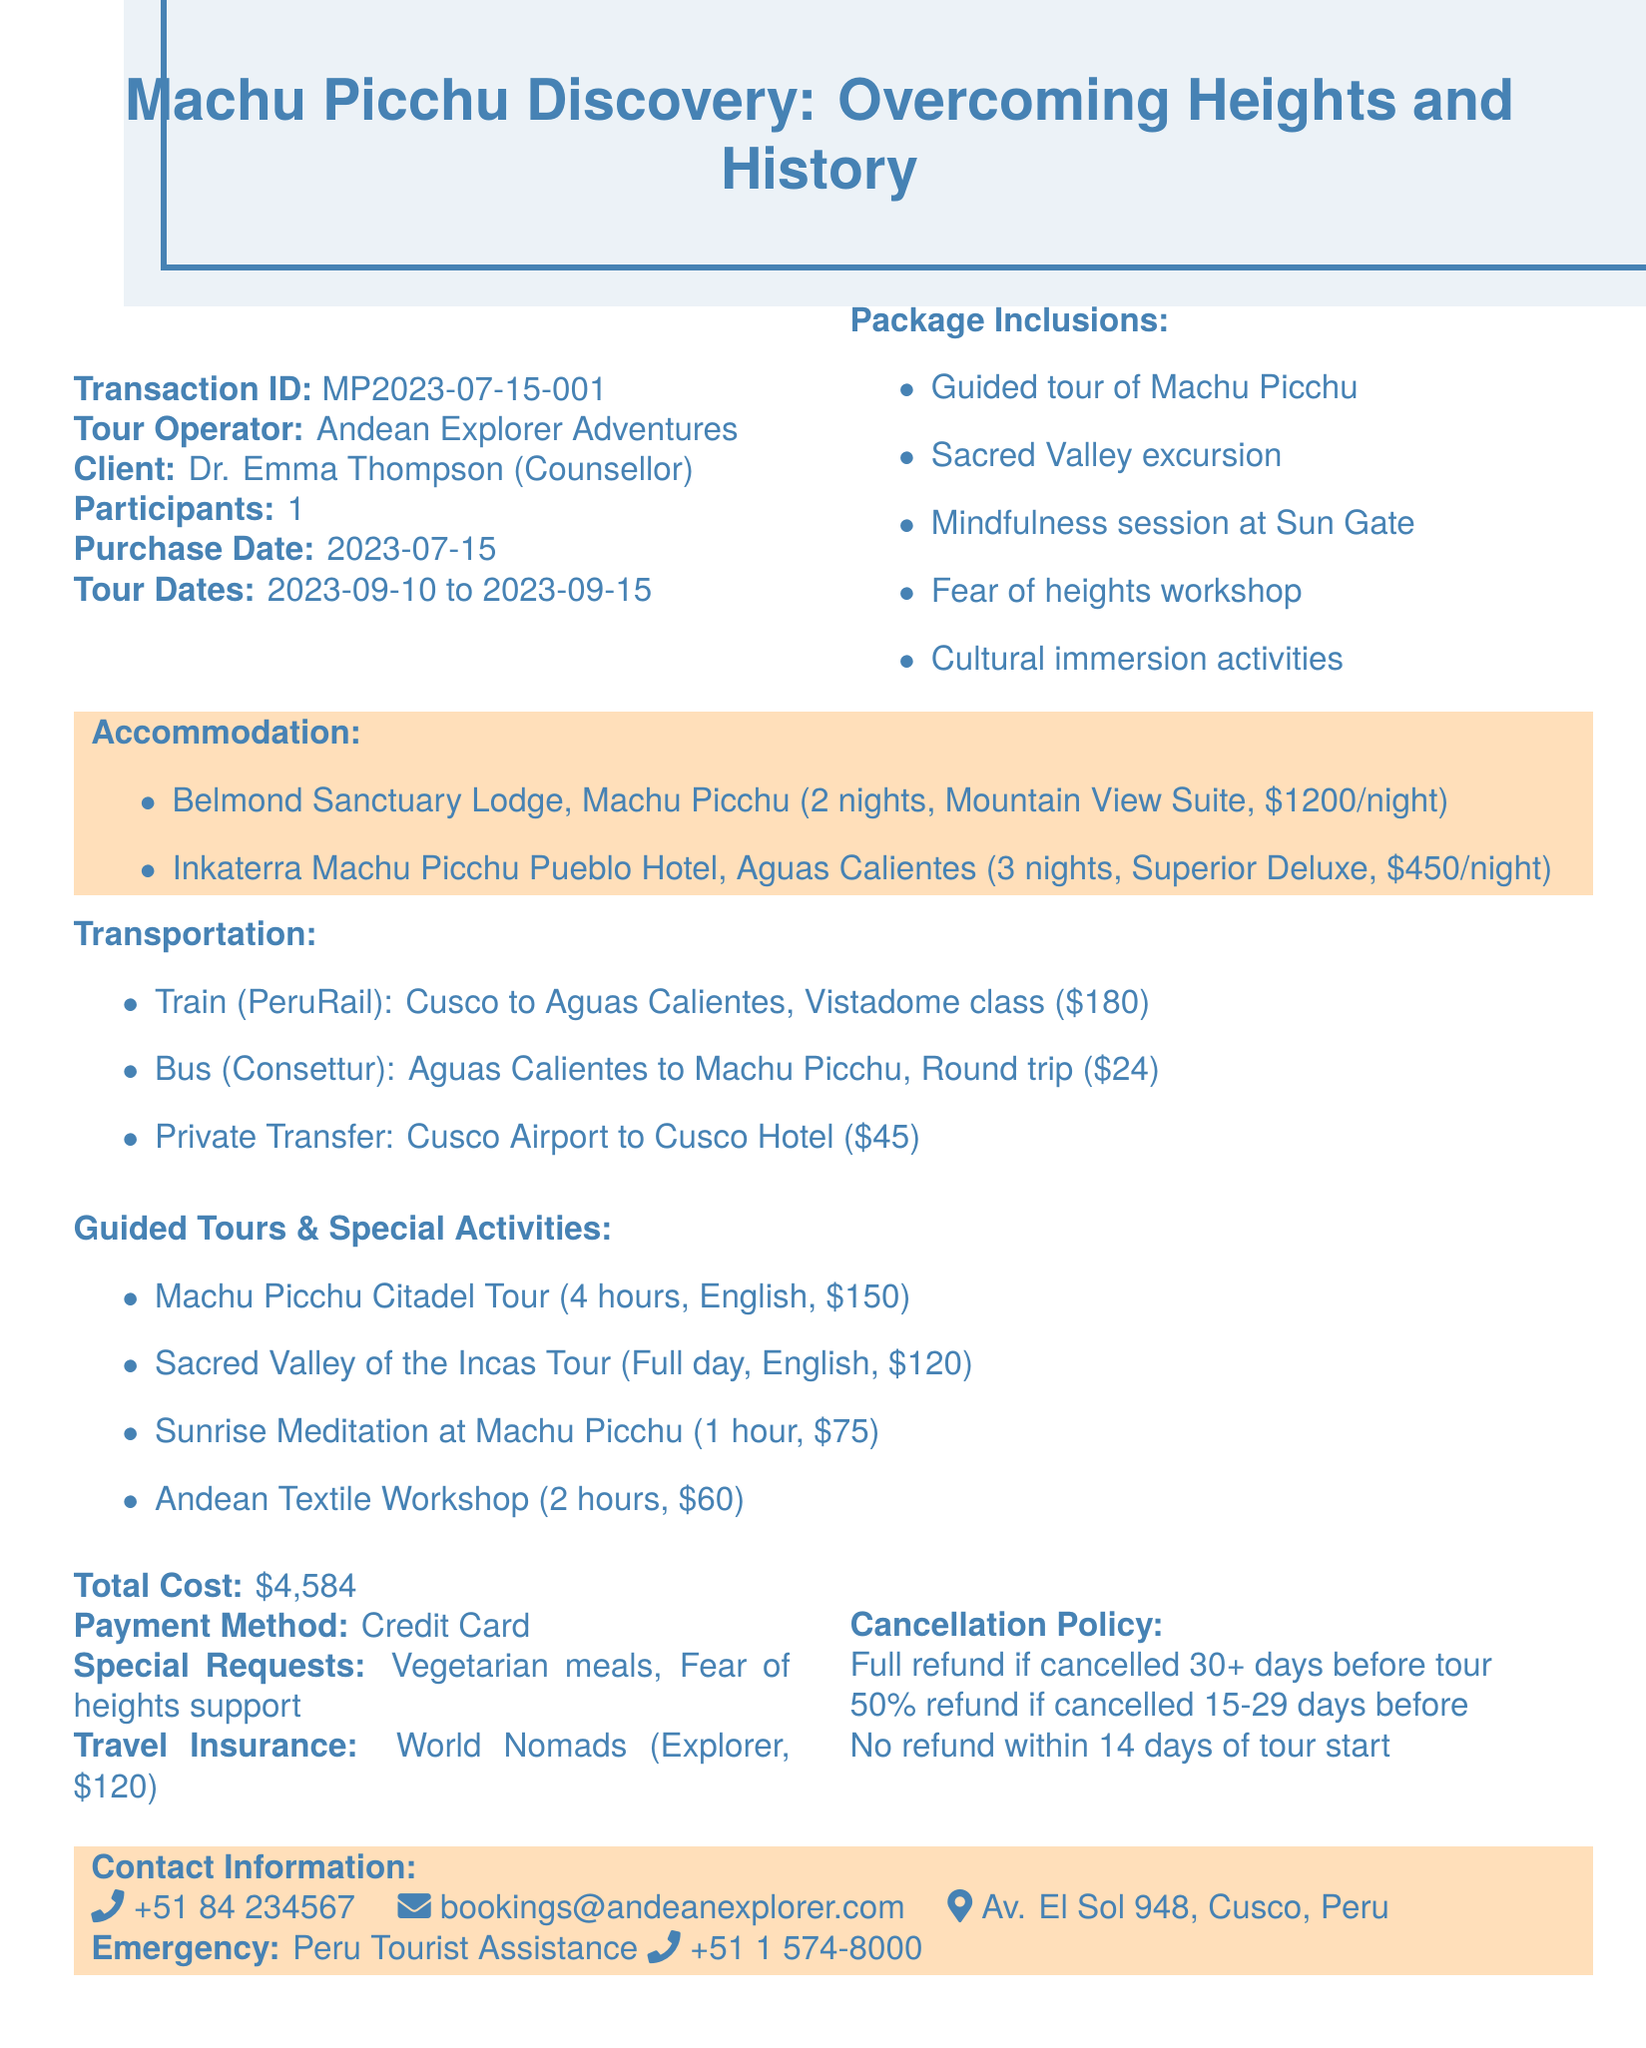What is the transaction ID? The transaction ID uniquely identifies the transaction in the document, here it is MP2023-07-15-001.
Answer: MP2023-07-15-001 Who is the client? The client's name is mentioned in the document, which is Dr. Emma Thompson.
Answer: Dr. Emma Thompson What is the start date of the tour? The start date is specified in the tour dates section of the document, which is 2023-09-10.
Answer: 2023-09-10 What type of room is at Belmond Sanctuary Lodge? The document specifies the room type at Belmond Sanctuary Lodge, which is Mountain View Suite.
Answer: Mountain View Suite What is the cost of the guided Machu Picchu Citadel Tour? The cost of the Machu Picchu Citadel Tour is detailed in the guided tours section, which is $150.
Answer: $150 How many nights will be spent at Inkaterra Machu Picchu Pueblo Hotel? The document indicates that 3 nights are booked at Inkaterra Machu Picchu Pueblo Hotel.
Answer: 3 nights What is the total cost of the tour package? The total cost summarises all expenses related to the tour package, indicated as $4,584 in the document.
Answer: $4,584 What special request did the client make? The special requests are mentioned in the document, which include vegetarian meals and fear of heights support.
Answer: Vegetarian meals, Fear of heights support What is the cancellation policy regarding refunds? The cancellation policy outlines refund conditions, including full and partial refunds based on cancellation timing.
Answer: Full refund if cancelled 30 days before the tour 